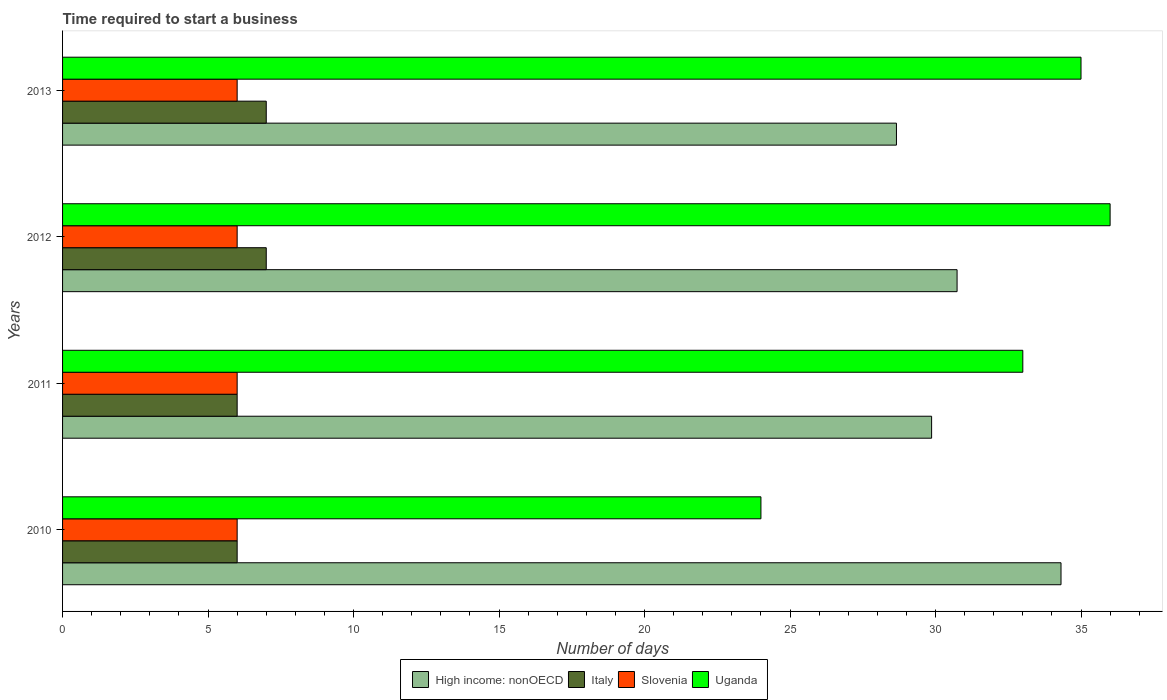How many different coloured bars are there?
Your answer should be compact. 4. Are the number of bars per tick equal to the number of legend labels?
Give a very brief answer. Yes. How many bars are there on the 4th tick from the bottom?
Your response must be concise. 4. What is the label of the 1st group of bars from the top?
Your answer should be compact. 2013. Across all years, what is the maximum number of days required to start a business in High income: nonOECD?
Offer a terse response. 34.31. Across all years, what is the minimum number of days required to start a business in Uganda?
Offer a very short reply. 24. What is the total number of days required to start a business in Slovenia in the graph?
Your answer should be compact. 24. What is the difference between the number of days required to start a business in High income: nonOECD in 2010 and that in 2011?
Provide a short and direct response. 4.45. What is the difference between the number of days required to start a business in Uganda in 2010 and the number of days required to start a business in High income: nonOECD in 2013?
Make the answer very short. -4.66. In the year 2013, what is the difference between the number of days required to start a business in Italy and number of days required to start a business in Slovenia?
Your answer should be very brief. 1. In how many years, is the number of days required to start a business in Italy greater than 34 days?
Make the answer very short. 0. What is the ratio of the number of days required to start a business in Slovenia in 2010 to that in 2013?
Make the answer very short. 1. Is the difference between the number of days required to start a business in Italy in 2010 and 2011 greater than the difference between the number of days required to start a business in Slovenia in 2010 and 2011?
Offer a very short reply. No. What is the difference between the highest and the second highest number of days required to start a business in Italy?
Your response must be concise. 0. What is the difference between the highest and the lowest number of days required to start a business in Slovenia?
Keep it short and to the point. 0. In how many years, is the number of days required to start a business in Uganda greater than the average number of days required to start a business in Uganda taken over all years?
Provide a succinct answer. 3. Is the sum of the number of days required to start a business in Italy in 2010 and 2011 greater than the maximum number of days required to start a business in High income: nonOECD across all years?
Your response must be concise. No. Is it the case that in every year, the sum of the number of days required to start a business in Uganda and number of days required to start a business in High income: nonOECD is greater than the sum of number of days required to start a business in Slovenia and number of days required to start a business in Italy?
Ensure brevity in your answer.  Yes. What does the 4th bar from the top in 2012 represents?
Offer a terse response. High income: nonOECD. How many years are there in the graph?
Your answer should be very brief. 4. Does the graph contain grids?
Give a very brief answer. No. Where does the legend appear in the graph?
Your answer should be compact. Bottom center. How many legend labels are there?
Provide a short and direct response. 4. How are the legend labels stacked?
Give a very brief answer. Horizontal. What is the title of the graph?
Your answer should be very brief. Time required to start a business. Does "Ireland" appear as one of the legend labels in the graph?
Provide a short and direct response. No. What is the label or title of the X-axis?
Make the answer very short. Number of days. What is the label or title of the Y-axis?
Provide a short and direct response. Years. What is the Number of days in High income: nonOECD in 2010?
Make the answer very short. 34.31. What is the Number of days in Uganda in 2010?
Provide a short and direct response. 24. What is the Number of days of High income: nonOECD in 2011?
Keep it short and to the point. 29.87. What is the Number of days of Italy in 2011?
Offer a terse response. 6. What is the Number of days in Uganda in 2011?
Your response must be concise. 33. What is the Number of days of High income: nonOECD in 2012?
Offer a terse response. 30.74. What is the Number of days in High income: nonOECD in 2013?
Your response must be concise. 28.66. What is the Number of days of Slovenia in 2013?
Provide a short and direct response. 6. What is the Number of days of Uganda in 2013?
Keep it short and to the point. 35. Across all years, what is the maximum Number of days in High income: nonOECD?
Make the answer very short. 34.31. Across all years, what is the maximum Number of days in Italy?
Offer a very short reply. 7. Across all years, what is the minimum Number of days of High income: nonOECD?
Keep it short and to the point. 28.66. Across all years, what is the minimum Number of days in Slovenia?
Ensure brevity in your answer.  6. Across all years, what is the minimum Number of days in Uganda?
Your answer should be very brief. 24. What is the total Number of days of High income: nonOECD in the graph?
Your response must be concise. 123.58. What is the total Number of days in Slovenia in the graph?
Your response must be concise. 24. What is the total Number of days of Uganda in the graph?
Provide a short and direct response. 128. What is the difference between the Number of days of High income: nonOECD in 2010 and that in 2011?
Your response must be concise. 4.45. What is the difference between the Number of days in Italy in 2010 and that in 2011?
Your answer should be very brief. 0. What is the difference between the Number of days in Uganda in 2010 and that in 2011?
Give a very brief answer. -9. What is the difference between the Number of days in High income: nonOECD in 2010 and that in 2012?
Give a very brief answer. 3.57. What is the difference between the Number of days in Uganda in 2010 and that in 2012?
Your answer should be compact. -12. What is the difference between the Number of days of High income: nonOECD in 2010 and that in 2013?
Your answer should be very brief. 5.66. What is the difference between the Number of days of Italy in 2010 and that in 2013?
Provide a succinct answer. -1. What is the difference between the Number of days in High income: nonOECD in 2011 and that in 2012?
Keep it short and to the point. -0.88. What is the difference between the Number of days in High income: nonOECD in 2011 and that in 2013?
Provide a succinct answer. 1.21. What is the difference between the Number of days of High income: nonOECD in 2012 and that in 2013?
Make the answer very short. 2.08. What is the difference between the Number of days in Slovenia in 2012 and that in 2013?
Offer a terse response. 0. What is the difference between the Number of days of High income: nonOECD in 2010 and the Number of days of Italy in 2011?
Keep it short and to the point. 28.31. What is the difference between the Number of days in High income: nonOECD in 2010 and the Number of days in Slovenia in 2011?
Offer a terse response. 28.31. What is the difference between the Number of days of High income: nonOECD in 2010 and the Number of days of Uganda in 2011?
Your response must be concise. 1.31. What is the difference between the Number of days of Italy in 2010 and the Number of days of Slovenia in 2011?
Give a very brief answer. 0. What is the difference between the Number of days of Italy in 2010 and the Number of days of Uganda in 2011?
Give a very brief answer. -27. What is the difference between the Number of days of High income: nonOECD in 2010 and the Number of days of Italy in 2012?
Ensure brevity in your answer.  27.31. What is the difference between the Number of days of High income: nonOECD in 2010 and the Number of days of Slovenia in 2012?
Keep it short and to the point. 28.31. What is the difference between the Number of days in High income: nonOECD in 2010 and the Number of days in Uganda in 2012?
Provide a short and direct response. -1.69. What is the difference between the Number of days of Italy in 2010 and the Number of days of Slovenia in 2012?
Keep it short and to the point. 0. What is the difference between the Number of days of High income: nonOECD in 2010 and the Number of days of Italy in 2013?
Give a very brief answer. 27.31. What is the difference between the Number of days of High income: nonOECD in 2010 and the Number of days of Slovenia in 2013?
Make the answer very short. 28.31. What is the difference between the Number of days in High income: nonOECD in 2010 and the Number of days in Uganda in 2013?
Give a very brief answer. -0.69. What is the difference between the Number of days of Italy in 2010 and the Number of days of Slovenia in 2013?
Give a very brief answer. 0. What is the difference between the Number of days in Italy in 2010 and the Number of days in Uganda in 2013?
Give a very brief answer. -29. What is the difference between the Number of days of High income: nonOECD in 2011 and the Number of days of Italy in 2012?
Offer a very short reply. 22.87. What is the difference between the Number of days of High income: nonOECD in 2011 and the Number of days of Slovenia in 2012?
Your response must be concise. 23.87. What is the difference between the Number of days of High income: nonOECD in 2011 and the Number of days of Uganda in 2012?
Keep it short and to the point. -6.13. What is the difference between the Number of days in Italy in 2011 and the Number of days in Slovenia in 2012?
Ensure brevity in your answer.  0. What is the difference between the Number of days of Italy in 2011 and the Number of days of Uganda in 2012?
Give a very brief answer. -30. What is the difference between the Number of days of Slovenia in 2011 and the Number of days of Uganda in 2012?
Make the answer very short. -30. What is the difference between the Number of days of High income: nonOECD in 2011 and the Number of days of Italy in 2013?
Provide a short and direct response. 22.87. What is the difference between the Number of days of High income: nonOECD in 2011 and the Number of days of Slovenia in 2013?
Your answer should be very brief. 23.87. What is the difference between the Number of days of High income: nonOECD in 2011 and the Number of days of Uganda in 2013?
Your response must be concise. -5.13. What is the difference between the Number of days in Italy in 2011 and the Number of days in Uganda in 2013?
Provide a succinct answer. -29. What is the difference between the Number of days in Slovenia in 2011 and the Number of days in Uganda in 2013?
Offer a very short reply. -29. What is the difference between the Number of days in High income: nonOECD in 2012 and the Number of days in Italy in 2013?
Your answer should be very brief. 23.74. What is the difference between the Number of days of High income: nonOECD in 2012 and the Number of days of Slovenia in 2013?
Your answer should be compact. 24.74. What is the difference between the Number of days of High income: nonOECD in 2012 and the Number of days of Uganda in 2013?
Offer a terse response. -4.26. What is the difference between the Number of days in Italy in 2012 and the Number of days in Slovenia in 2013?
Provide a succinct answer. 1. What is the average Number of days of High income: nonOECD per year?
Your answer should be compact. 30.89. What is the average Number of days in Italy per year?
Ensure brevity in your answer.  6.5. What is the average Number of days in Slovenia per year?
Your answer should be compact. 6. In the year 2010, what is the difference between the Number of days in High income: nonOECD and Number of days in Italy?
Ensure brevity in your answer.  28.31. In the year 2010, what is the difference between the Number of days in High income: nonOECD and Number of days in Slovenia?
Make the answer very short. 28.31. In the year 2010, what is the difference between the Number of days of High income: nonOECD and Number of days of Uganda?
Give a very brief answer. 10.31. In the year 2011, what is the difference between the Number of days of High income: nonOECD and Number of days of Italy?
Make the answer very short. 23.87. In the year 2011, what is the difference between the Number of days of High income: nonOECD and Number of days of Slovenia?
Give a very brief answer. 23.87. In the year 2011, what is the difference between the Number of days in High income: nonOECD and Number of days in Uganda?
Offer a very short reply. -3.13. In the year 2011, what is the difference between the Number of days of Italy and Number of days of Uganda?
Keep it short and to the point. -27. In the year 2012, what is the difference between the Number of days of High income: nonOECD and Number of days of Italy?
Ensure brevity in your answer.  23.74. In the year 2012, what is the difference between the Number of days in High income: nonOECD and Number of days in Slovenia?
Give a very brief answer. 24.74. In the year 2012, what is the difference between the Number of days in High income: nonOECD and Number of days in Uganda?
Your answer should be compact. -5.26. In the year 2012, what is the difference between the Number of days in Italy and Number of days in Slovenia?
Your response must be concise. 1. In the year 2012, what is the difference between the Number of days in Slovenia and Number of days in Uganda?
Offer a very short reply. -30. In the year 2013, what is the difference between the Number of days in High income: nonOECD and Number of days in Italy?
Keep it short and to the point. 21.66. In the year 2013, what is the difference between the Number of days of High income: nonOECD and Number of days of Slovenia?
Offer a terse response. 22.66. In the year 2013, what is the difference between the Number of days in High income: nonOECD and Number of days in Uganda?
Make the answer very short. -6.34. In the year 2013, what is the difference between the Number of days of Italy and Number of days of Slovenia?
Ensure brevity in your answer.  1. In the year 2013, what is the difference between the Number of days in Italy and Number of days in Uganda?
Your answer should be compact. -28. What is the ratio of the Number of days of High income: nonOECD in 2010 to that in 2011?
Give a very brief answer. 1.15. What is the ratio of the Number of days in Italy in 2010 to that in 2011?
Your response must be concise. 1. What is the ratio of the Number of days of Slovenia in 2010 to that in 2011?
Provide a succinct answer. 1. What is the ratio of the Number of days of Uganda in 2010 to that in 2011?
Your answer should be compact. 0.73. What is the ratio of the Number of days of High income: nonOECD in 2010 to that in 2012?
Ensure brevity in your answer.  1.12. What is the ratio of the Number of days of Slovenia in 2010 to that in 2012?
Keep it short and to the point. 1. What is the ratio of the Number of days in Uganda in 2010 to that in 2012?
Keep it short and to the point. 0.67. What is the ratio of the Number of days of High income: nonOECD in 2010 to that in 2013?
Offer a terse response. 1.2. What is the ratio of the Number of days of Italy in 2010 to that in 2013?
Keep it short and to the point. 0.86. What is the ratio of the Number of days of Slovenia in 2010 to that in 2013?
Give a very brief answer. 1. What is the ratio of the Number of days of Uganda in 2010 to that in 2013?
Give a very brief answer. 0.69. What is the ratio of the Number of days in High income: nonOECD in 2011 to that in 2012?
Make the answer very short. 0.97. What is the ratio of the Number of days in Slovenia in 2011 to that in 2012?
Your response must be concise. 1. What is the ratio of the Number of days of High income: nonOECD in 2011 to that in 2013?
Your answer should be very brief. 1.04. What is the ratio of the Number of days of Italy in 2011 to that in 2013?
Give a very brief answer. 0.86. What is the ratio of the Number of days of Slovenia in 2011 to that in 2013?
Provide a short and direct response. 1. What is the ratio of the Number of days of Uganda in 2011 to that in 2013?
Your response must be concise. 0.94. What is the ratio of the Number of days of High income: nonOECD in 2012 to that in 2013?
Make the answer very short. 1.07. What is the ratio of the Number of days of Slovenia in 2012 to that in 2013?
Make the answer very short. 1. What is the ratio of the Number of days of Uganda in 2012 to that in 2013?
Provide a short and direct response. 1.03. What is the difference between the highest and the second highest Number of days of High income: nonOECD?
Ensure brevity in your answer.  3.57. What is the difference between the highest and the second highest Number of days in Italy?
Provide a succinct answer. 0. What is the difference between the highest and the second highest Number of days in Slovenia?
Ensure brevity in your answer.  0. What is the difference between the highest and the second highest Number of days in Uganda?
Your response must be concise. 1. What is the difference between the highest and the lowest Number of days of High income: nonOECD?
Your response must be concise. 5.66. What is the difference between the highest and the lowest Number of days of Italy?
Ensure brevity in your answer.  1. What is the difference between the highest and the lowest Number of days in Uganda?
Your response must be concise. 12. 